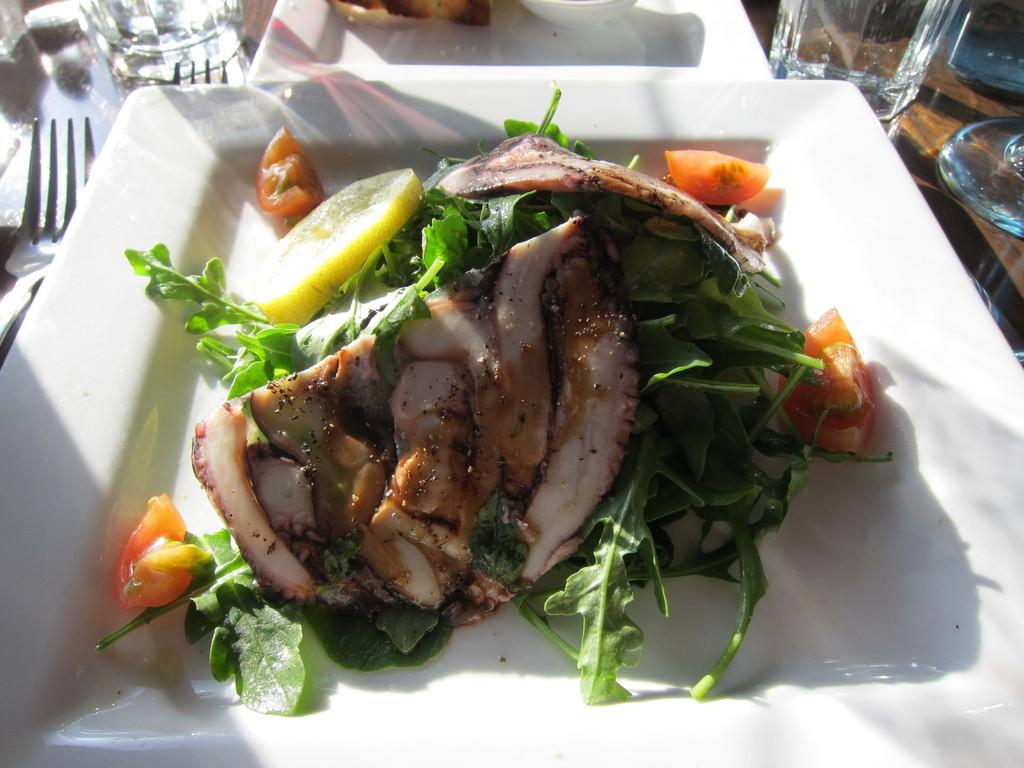What color is the plate that holds the food item in the image? The plate is white. What utensils can be seen in the image? There are forks visible in the image. What type of tableware is present in the image besides forks? There are glasses in the image. How many plates can be seen in the image? There is at least one additional plate in the image. Can you see any tomatoes being kicked in the image? There are no tomatoes or any kicking activity present in the image. 